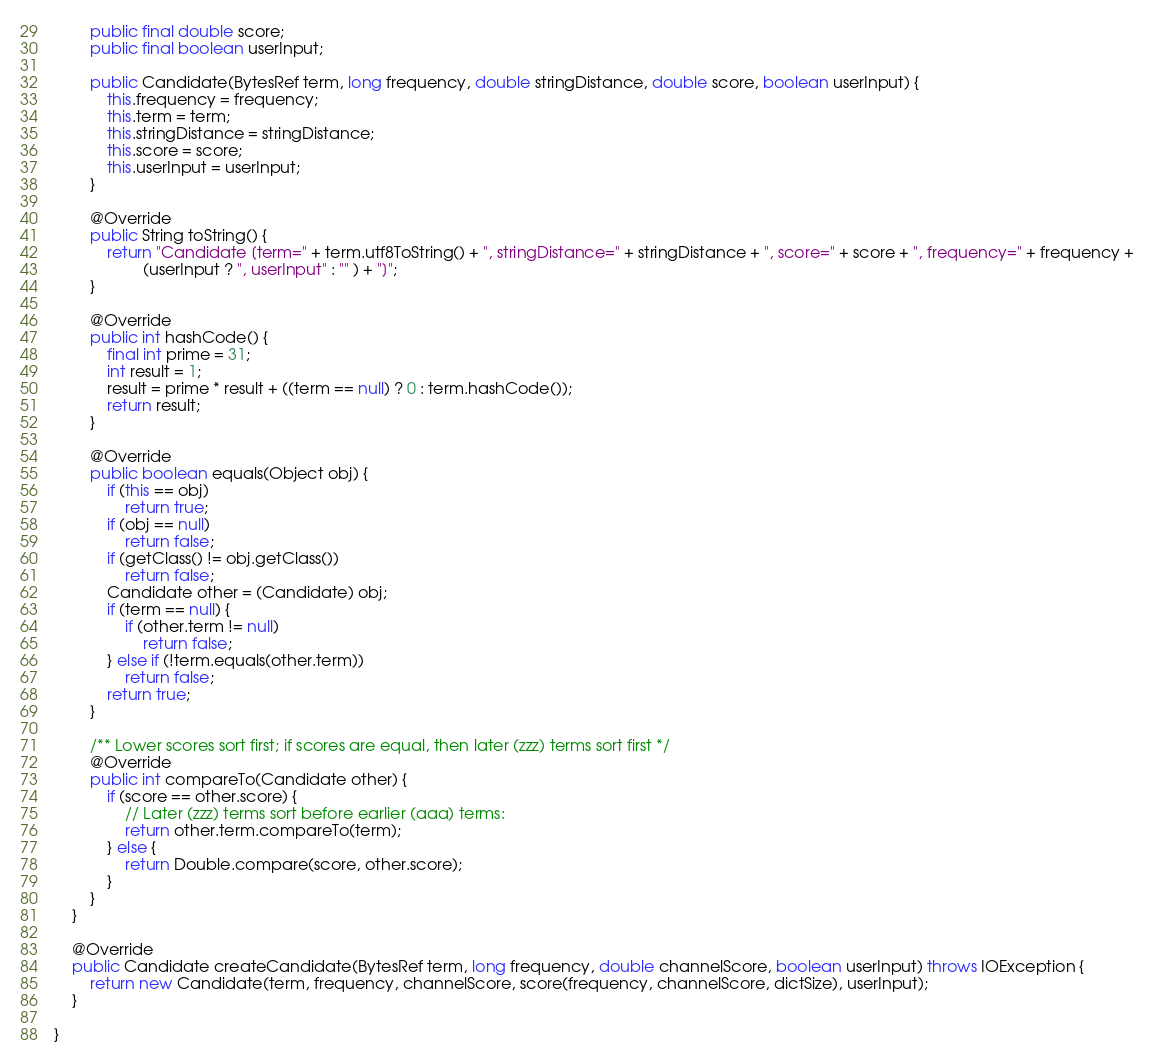<code> <loc_0><loc_0><loc_500><loc_500><_Java_>        public final double score;
        public final boolean userInput;

        public Candidate(BytesRef term, long frequency, double stringDistance, double score, boolean userInput) {
            this.frequency = frequency;
            this.term = term;
            this.stringDistance = stringDistance;
            this.score = score;
            this.userInput = userInput;
        }

        @Override
        public String toString() {
            return "Candidate [term=" + term.utf8ToString() + ", stringDistance=" + stringDistance + ", score=" + score + ", frequency=" + frequency + 
                    (userInput ? ", userInput" : "" ) + "]";
        }

        @Override
        public int hashCode() {
            final int prime = 31;
            int result = 1;
            result = prime * result + ((term == null) ? 0 : term.hashCode());
            return result;
        }

        @Override
        public boolean equals(Object obj) {
            if (this == obj)
                return true;
            if (obj == null)
                return false;
            if (getClass() != obj.getClass())
                return false;
            Candidate other = (Candidate) obj;
            if (term == null) {
                if (other.term != null)
                    return false;
            } else if (!term.equals(other.term))
                return false;
            return true;
        }

        /** Lower scores sort first; if scores are equal, then later (zzz) terms sort first */
        @Override
        public int compareTo(Candidate other) {
            if (score == other.score) {
                // Later (zzz) terms sort before earlier (aaa) terms:
                return other.term.compareTo(term);
            } else {
                return Double.compare(score, other.score);
            }
        }
    }

    @Override
    public Candidate createCandidate(BytesRef term, long frequency, double channelScore, boolean userInput) throws IOException {
        return new Candidate(term, frequency, channelScore, score(frequency, channelScore, dictSize), userInput);
    }

}
</code> 